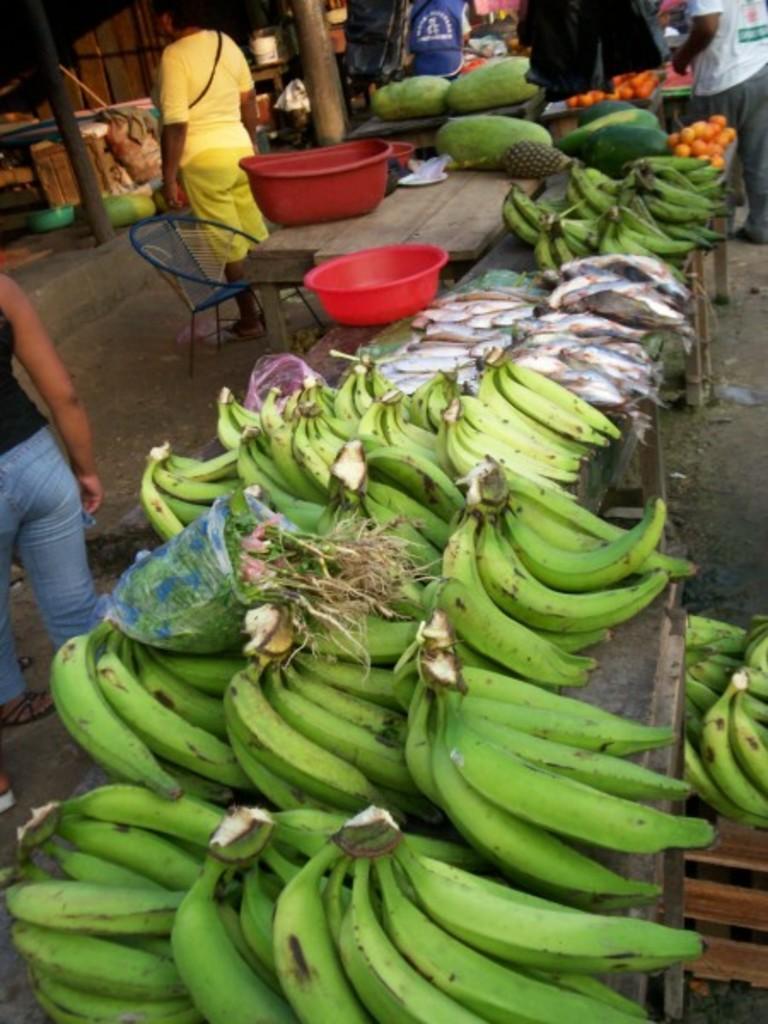Describe this image in one or two sentences. In this image in front there are bananas, fishes, tomatoes, tubs and a few other vegetables on the tables. Beside the table there is a chair. There are people. In the background of the image there are pillars and a few other objects. 